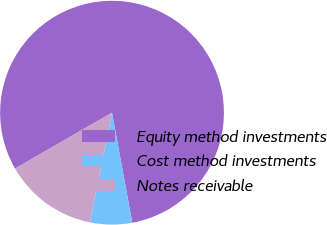Convert chart to OTSL. <chart><loc_0><loc_0><loc_500><loc_500><pie_chart><fcel>Equity method investments<fcel>Cost method investments<fcel>Notes receivable<nl><fcel>80.42%<fcel>6.07%<fcel>13.51%<nl></chart> 